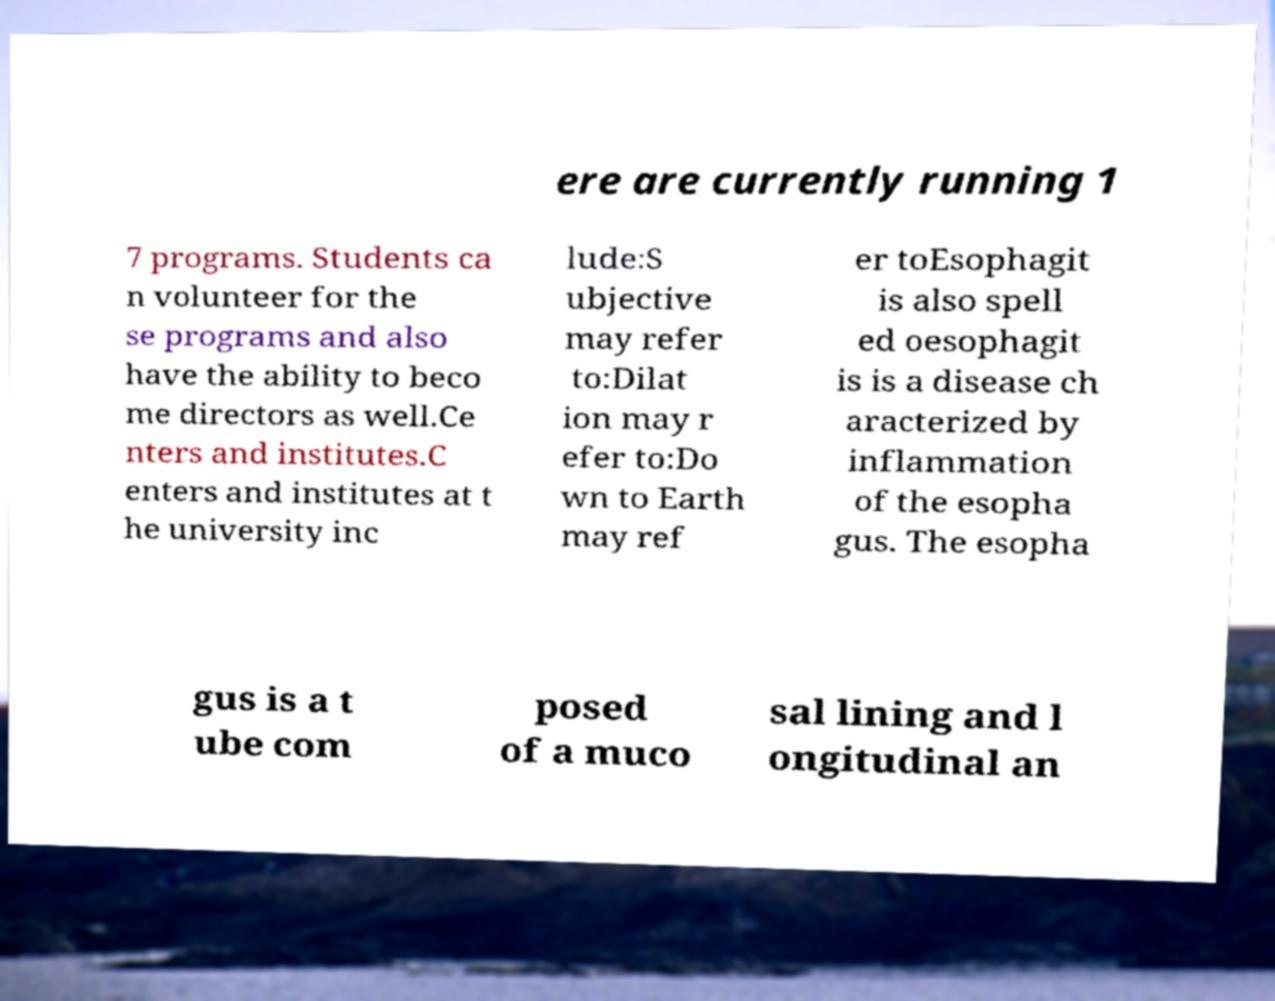Please read and relay the text visible in this image. What does it say? ere are currently running 1 7 programs. Students ca n volunteer for the se programs and also have the ability to beco me directors as well.Ce nters and institutes.C enters and institutes at t he university inc lude:S ubjective may refer to:Dilat ion may r efer to:Do wn to Earth may ref er toEsophagit is also spell ed oesophagit is is a disease ch aracterized by inflammation of the esopha gus. The esopha gus is a t ube com posed of a muco sal lining and l ongitudinal an 